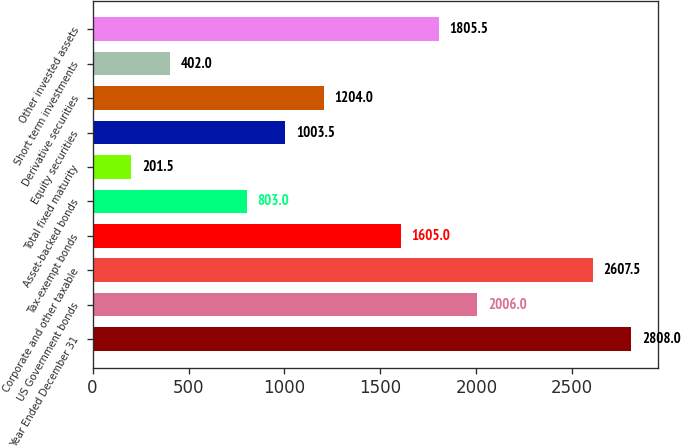Convert chart to OTSL. <chart><loc_0><loc_0><loc_500><loc_500><bar_chart><fcel>Year Ended December 31<fcel>US Government bonds<fcel>Corporate and other taxable<fcel>Tax-exempt bonds<fcel>Asset-backed bonds<fcel>Total fixed maturity<fcel>Equity securities<fcel>Derivative securities<fcel>Short term investments<fcel>Other invested assets<nl><fcel>2808<fcel>2006<fcel>2607.5<fcel>1605<fcel>803<fcel>201.5<fcel>1003.5<fcel>1204<fcel>402<fcel>1805.5<nl></chart> 